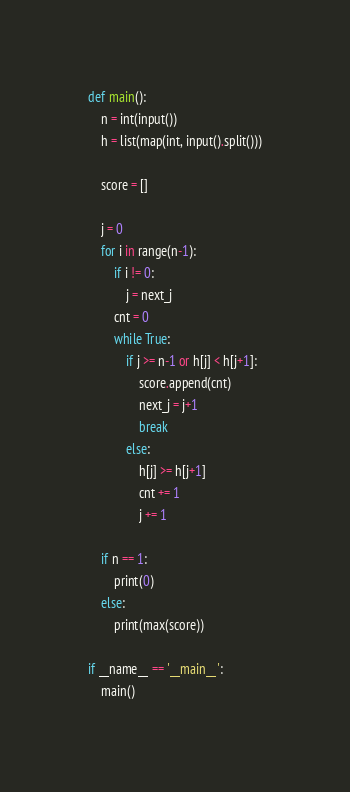Convert code to text. <code><loc_0><loc_0><loc_500><loc_500><_Python_>def main():
    n = int(input())
    h = list(map(int, input().split()))

    score = []

    j = 0
    for i in range(n-1):
        if i != 0:
            j = next_j
        cnt = 0
        while True:
            if j >= n-1 or h[j] < h[j+1]:
                score.append(cnt)
                next_j = j+1
                break
            else:
                h[j] >= h[j+1]
                cnt += 1
                j += 1

    if n == 1:
        print(0)
    else:
        print(max(score))

if __name__ == '__main__':
    main()</code> 